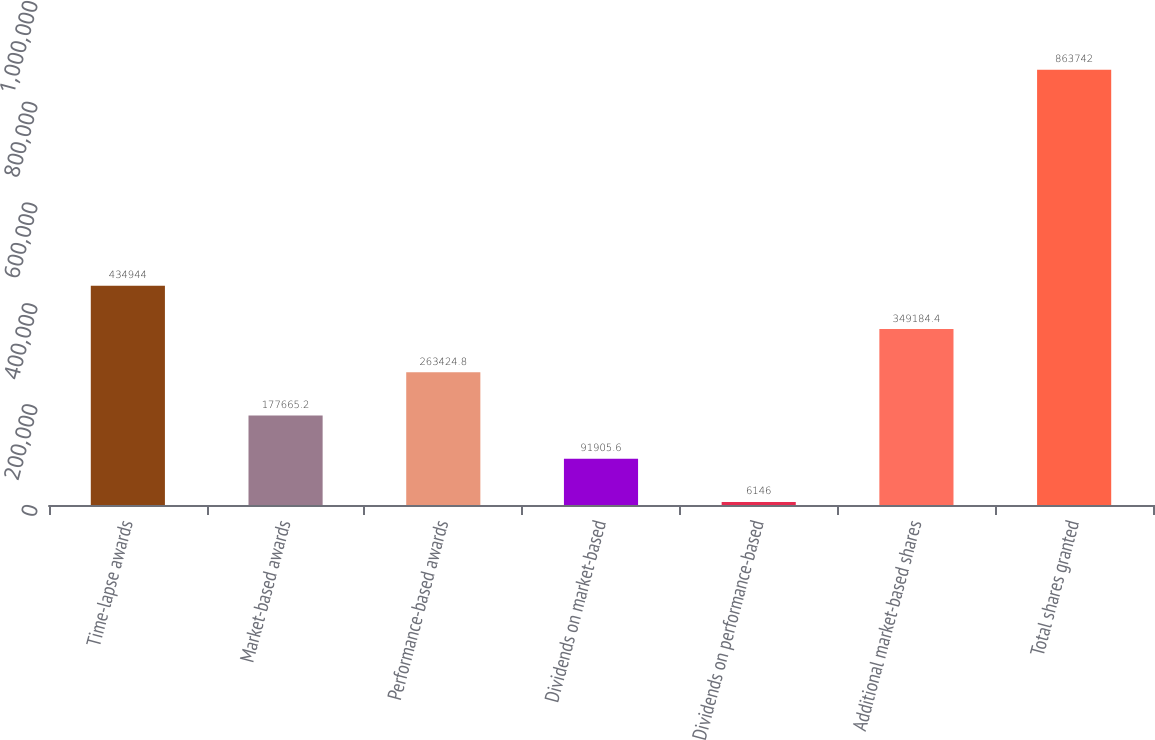<chart> <loc_0><loc_0><loc_500><loc_500><bar_chart><fcel>Time-lapse awards<fcel>Market-based awards<fcel>Performance-based awards<fcel>Dividends on market-based<fcel>Dividends on performance-based<fcel>Additional market-based shares<fcel>Total shares granted<nl><fcel>434944<fcel>177665<fcel>263425<fcel>91905.6<fcel>6146<fcel>349184<fcel>863742<nl></chart> 